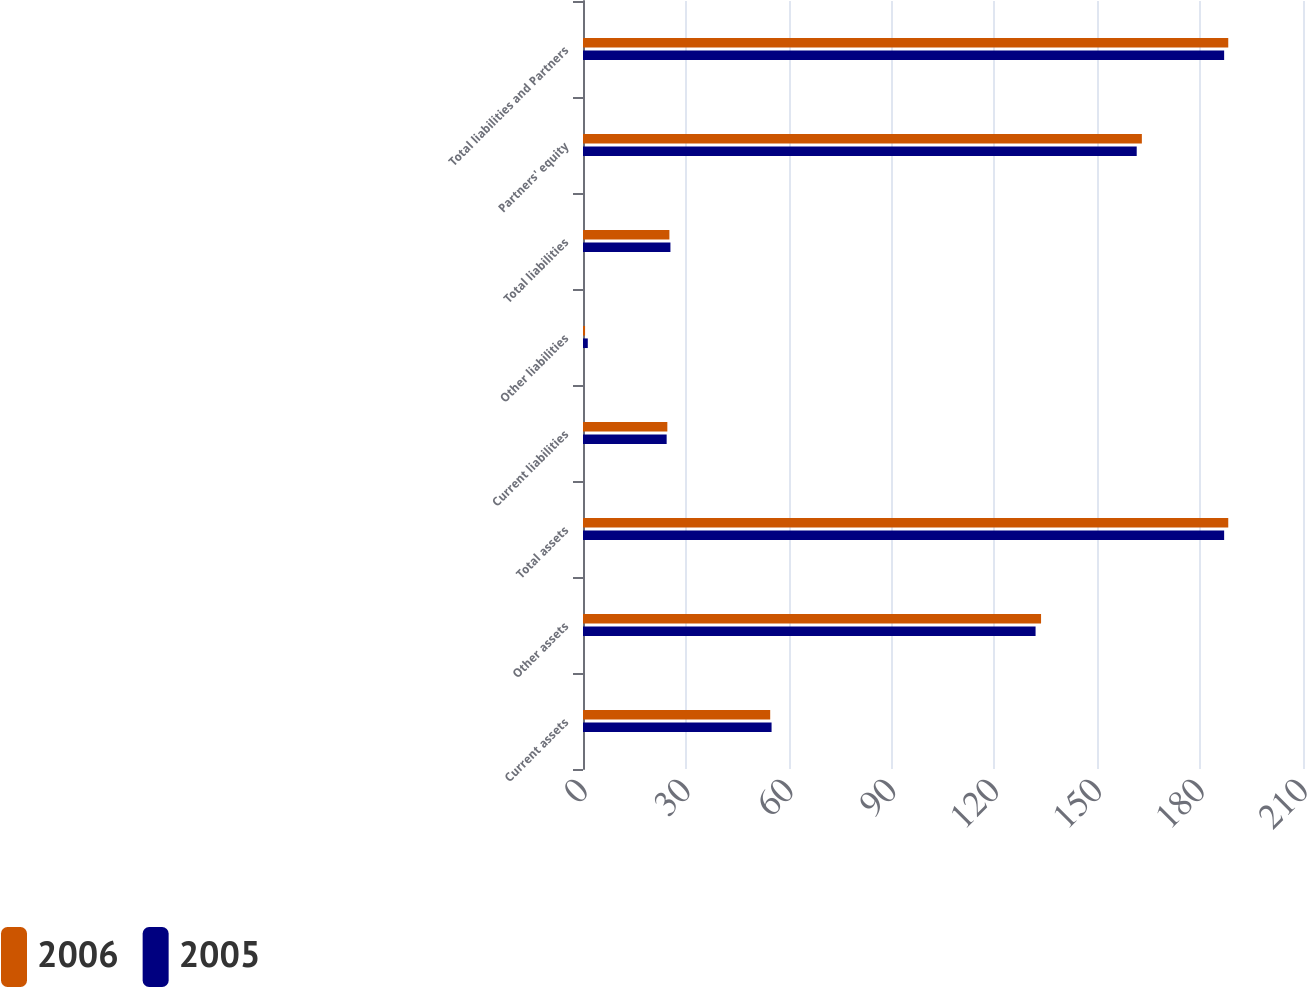Convert chart to OTSL. <chart><loc_0><loc_0><loc_500><loc_500><stacked_bar_chart><ecel><fcel>Current assets<fcel>Other assets<fcel>Total assets<fcel>Current liabilities<fcel>Other liabilities<fcel>Total liabilities<fcel>Partners' equity<fcel>Total liabilities and Partners<nl><fcel>2006<fcel>54.6<fcel>133.6<fcel>188.2<fcel>24.6<fcel>0.6<fcel>25.2<fcel>163<fcel>188.2<nl><fcel>2005<fcel>55<fcel>132<fcel>187<fcel>24.4<fcel>1.4<fcel>25.5<fcel>161.5<fcel>187<nl></chart> 